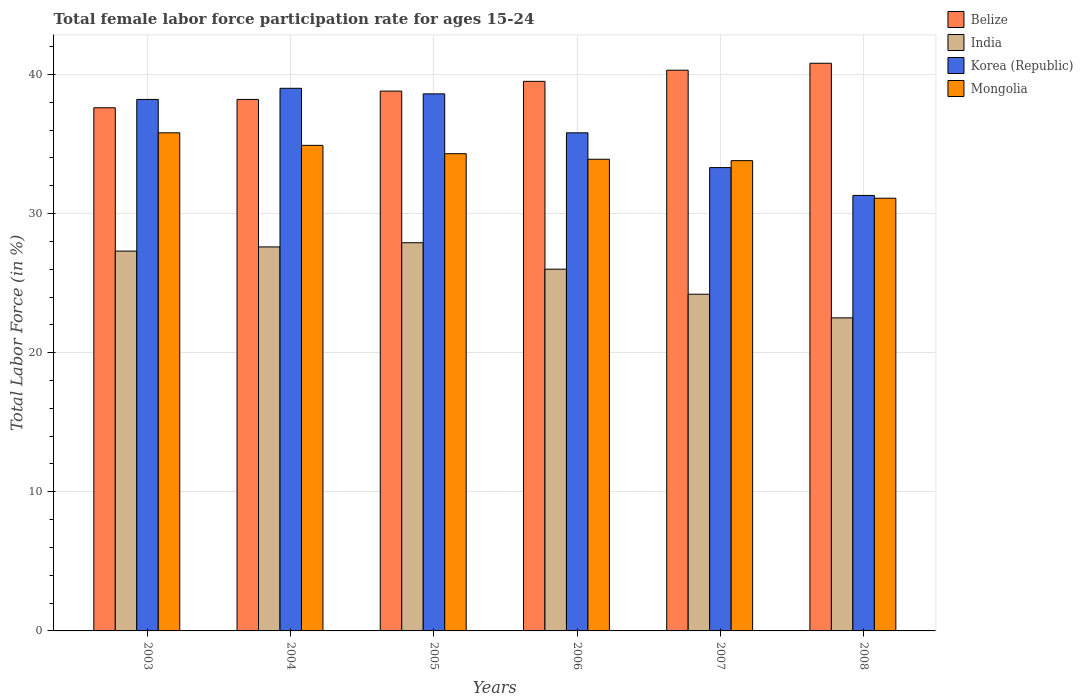How many groups of bars are there?
Provide a short and direct response. 6. Are the number of bars on each tick of the X-axis equal?
Offer a very short reply. Yes. How many bars are there on the 2nd tick from the left?
Keep it short and to the point. 4. In how many cases, is the number of bars for a given year not equal to the number of legend labels?
Your response must be concise. 0. What is the female labor force participation rate in India in 2006?
Provide a short and direct response. 26. Across all years, what is the minimum female labor force participation rate in Mongolia?
Offer a very short reply. 31.1. In which year was the female labor force participation rate in Belize maximum?
Provide a short and direct response. 2008. In which year was the female labor force participation rate in Korea (Republic) minimum?
Give a very brief answer. 2008. What is the total female labor force participation rate in Belize in the graph?
Your answer should be very brief. 235.2. What is the difference between the female labor force participation rate in Mongolia in 2003 and that in 2005?
Provide a short and direct response. 1.5. What is the difference between the female labor force participation rate in India in 2007 and the female labor force participation rate in Korea (Republic) in 2003?
Provide a short and direct response. -14. What is the average female labor force participation rate in Mongolia per year?
Ensure brevity in your answer.  33.97. In the year 2008, what is the difference between the female labor force participation rate in Korea (Republic) and female labor force participation rate in India?
Your answer should be very brief. 8.8. What is the ratio of the female labor force participation rate in Mongolia in 2005 to that in 2006?
Provide a succinct answer. 1.01. What is the difference between the highest and the second highest female labor force participation rate in India?
Offer a terse response. 0.3. What is the difference between the highest and the lowest female labor force participation rate in Mongolia?
Ensure brevity in your answer.  4.7. What does the 4th bar from the left in 2003 represents?
Provide a short and direct response. Mongolia. Does the graph contain any zero values?
Provide a succinct answer. No. How many legend labels are there?
Keep it short and to the point. 4. How are the legend labels stacked?
Make the answer very short. Vertical. What is the title of the graph?
Your response must be concise. Total female labor force participation rate for ages 15-24. Does "Somalia" appear as one of the legend labels in the graph?
Offer a very short reply. No. What is the Total Labor Force (in %) of Belize in 2003?
Keep it short and to the point. 37.6. What is the Total Labor Force (in %) in India in 2003?
Provide a succinct answer. 27.3. What is the Total Labor Force (in %) of Korea (Republic) in 2003?
Provide a succinct answer. 38.2. What is the Total Labor Force (in %) of Mongolia in 2003?
Keep it short and to the point. 35.8. What is the Total Labor Force (in %) of Belize in 2004?
Your answer should be compact. 38.2. What is the Total Labor Force (in %) in India in 2004?
Provide a succinct answer. 27.6. What is the Total Labor Force (in %) in Mongolia in 2004?
Keep it short and to the point. 34.9. What is the Total Labor Force (in %) in Belize in 2005?
Give a very brief answer. 38.8. What is the Total Labor Force (in %) of India in 2005?
Ensure brevity in your answer.  27.9. What is the Total Labor Force (in %) of Korea (Republic) in 2005?
Your answer should be very brief. 38.6. What is the Total Labor Force (in %) in Mongolia in 2005?
Offer a terse response. 34.3. What is the Total Labor Force (in %) of Belize in 2006?
Your answer should be compact. 39.5. What is the Total Labor Force (in %) in Korea (Republic) in 2006?
Your answer should be compact. 35.8. What is the Total Labor Force (in %) in Mongolia in 2006?
Offer a very short reply. 33.9. What is the Total Labor Force (in %) of Belize in 2007?
Make the answer very short. 40.3. What is the Total Labor Force (in %) of India in 2007?
Give a very brief answer. 24.2. What is the Total Labor Force (in %) in Korea (Republic) in 2007?
Ensure brevity in your answer.  33.3. What is the Total Labor Force (in %) in Mongolia in 2007?
Ensure brevity in your answer.  33.8. What is the Total Labor Force (in %) of Belize in 2008?
Offer a terse response. 40.8. What is the Total Labor Force (in %) in Korea (Republic) in 2008?
Keep it short and to the point. 31.3. What is the Total Labor Force (in %) of Mongolia in 2008?
Make the answer very short. 31.1. Across all years, what is the maximum Total Labor Force (in %) of Belize?
Provide a succinct answer. 40.8. Across all years, what is the maximum Total Labor Force (in %) of India?
Give a very brief answer. 27.9. Across all years, what is the maximum Total Labor Force (in %) in Mongolia?
Your answer should be compact. 35.8. Across all years, what is the minimum Total Labor Force (in %) in Belize?
Make the answer very short. 37.6. Across all years, what is the minimum Total Labor Force (in %) in India?
Your answer should be very brief. 22.5. Across all years, what is the minimum Total Labor Force (in %) of Korea (Republic)?
Keep it short and to the point. 31.3. Across all years, what is the minimum Total Labor Force (in %) in Mongolia?
Provide a short and direct response. 31.1. What is the total Total Labor Force (in %) of Belize in the graph?
Your response must be concise. 235.2. What is the total Total Labor Force (in %) of India in the graph?
Offer a terse response. 155.5. What is the total Total Labor Force (in %) in Korea (Republic) in the graph?
Your answer should be compact. 216.2. What is the total Total Labor Force (in %) in Mongolia in the graph?
Your answer should be compact. 203.8. What is the difference between the Total Labor Force (in %) of India in 2003 and that in 2004?
Your answer should be compact. -0.3. What is the difference between the Total Labor Force (in %) in Korea (Republic) in 2003 and that in 2004?
Your answer should be compact. -0.8. What is the difference between the Total Labor Force (in %) of Mongolia in 2003 and that in 2004?
Offer a terse response. 0.9. What is the difference between the Total Labor Force (in %) in Korea (Republic) in 2003 and that in 2005?
Give a very brief answer. -0.4. What is the difference between the Total Labor Force (in %) of Mongolia in 2003 and that in 2005?
Offer a terse response. 1.5. What is the difference between the Total Labor Force (in %) in India in 2003 and that in 2007?
Your answer should be compact. 3.1. What is the difference between the Total Labor Force (in %) in Belize in 2003 and that in 2008?
Your response must be concise. -3.2. What is the difference between the Total Labor Force (in %) of Mongolia in 2003 and that in 2008?
Your response must be concise. 4.7. What is the difference between the Total Labor Force (in %) of India in 2004 and that in 2005?
Offer a terse response. -0.3. What is the difference between the Total Labor Force (in %) of Korea (Republic) in 2004 and that in 2005?
Offer a very short reply. 0.4. What is the difference between the Total Labor Force (in %) of Belize in 2004 and that in 2006?
Keep it short and to the point. -1.3. What is the difference between the Total Labor Force (in %) of India in 2004 and that in 2006?
Give a very brief answer. 1.6. What is the difference between the Total Labor Force (in %) in Korea (Republic) in 2004 and that in 2006?
Keep it short and to the point. 3.2. What is the difference between the Total Labor Force (in %) of Belize in 2004 and that in 2007?
Offer a terse response. -2.1. What is the difference between the Total Labor Force (in %) of India in 2004 and that in 2007?
Keep it short and to the point. 3.4. What is the difference between the Total Labor Force (in %) in Korea (Republic) in 2004 and that in 2007?
Give a very brief answer. 5.7. What is the difference between the Total Labor Force (in %) in Mongolia in 2004 and that in 2007?
Your answer should be compact. 1.1. What is the difference between the Total Labor Force (in %) of Belize in 2004 and that in 2008?
Provide a succinct answer. -2.6. What is the difference between the Total Labor Force (in %) in India in 2004 and that in 2008?
Give a very brief answer. 5.1. What is the difference between the Total Labor Force (in %) in Belize in 2005 and that in 2006?
Keep it short and to the point. -0.7. What is the difference between the Total Labor Force (in %) of Korea (Republic) in 2005 and that in 2006?
Ensure brevity in your answer.  2.8. What is the difference between the Total Labor Force (in %) of Mongolia in 2005 and that in 2006?
Your answer should be compact. 0.4. What is the difference between the Total Labor Force (in %) in Belize in 2005 and that in 2007?
Make the answer very short. -1.5. What is the difference between the Total Labor Force (in %) of India in 2005 and that in 2007?
Provide a succinct answer. 3.7. What is the difference between the Total Labor Force (in %) of India in 2005 and that in 2008?
Your answer should be very brief. 5.4. What is the difference between the Total Labor Force (in %) in Mongolia in 2005 and that in 2008?
Offer a very short reply. 3.2. What is the difference between the Total Labor Force (in %) of India in 2006 and that in 2007?
Provide a short and direct response. 1.8. What is the difference between the Total Labor Force (in %) in Belize in 2006 and that in 2008?
Keep it short and to the point. -1.3. What is the difference between the Total Labor Force (in %) in Belize in 2003 and the Total Labor Force (in %) in India in 2004?
Ensure brevity in your answer.  10. What is the difference between the Total Labor Force (in %) of Belize in 2003 and the Total Labor Force (in %) of Korea (Republic) in 2004?
Offer a very short reply. -1.4. What is the difference between the Total Labor Force (in %) in Korea (Republic) in 2003 and the Total Labor Force (in %) in Mongolia in 2004?
Provide a succinct answer. 3.3. What is the difference between the Total Labor Force (in %) of Belize in 2003 and the Total Labor Force (in %) of India in 2005?
Provide a succinct answer. 9.7. What is the difference between the Total Labor Force (in %) in Belize in 2003 and the Total Labor Force (in %) in Korea (Republic) in 2005?
Your answer should be very brief. -1. What is the difference between the Total Labor Force (in %) in Belize in 2003 and the Total Labor Force (in %) in Mongolia in 2005?
Provide a succinct answer. 3.3. What is the difference between the Total Labor Force (in %) in Belize in 2003 and the Total Labor Force (in %) in India in 2006?
Provide a succinct answer. 11.6. What is the difference between the Total Labor Force (in %) of India in 2003 and the Total Labor Force (in %) of Korea (Republic) in 2006?
Offer a very short reply. -8.5. What is the difference between the Total Labor Force (in %) of Korea (Republic) in 2003 and the Total Labor Force (in %) of Mongolia in 2006?
Give a very brief answer. 4.3. What is the difference between the Total Labor Force (in %) of Belize in 2003 and the Total Labor Force (in %) of India in 2007?
Your response must be concise. 13.4. What is the difference between the Total Labor Force (in %) in Belize in 2003 and the Total Labor Force (in %) in Mongolia in 2007?
Ensure brevity in your answer.  3.8. What is the difference between the Total Labor Force (in %) in India in 2003 and the Total Labor Force (in %) in Mongolia in 2007?
Give a very brief answer. -6.5. What is the difference between the Total Labor Force (in %) in Belize in 2003 and the Total Labor Force (in %) in Korea (Republic) in 2008?
Keep it short and to the point. 6.3. What is the difference between the Total Labor Force (in %) of India in 2003 and the Total Labor Force (in %) of Korea (Republic) in 2008?
Your answer should be compact. -4. What is the difference between the Total Labor Force (in %) in India in 2003 and the Total Labor Force (in %) in Mongolia in 2008?
Provide a succinct answer. -3.8. What is the difference between the Total Labor Force (in %) in Belize in 2004 and the Total Labor Force (in %) in Korea (Republic) in 2005?
Offer a terse response. -0.4. What is the difference between the Total Labor Force (in %) of Belize in 2004 and the Total Labor Force (in %) of Mongolia in 2005?
Keep it short and to the point. 3.9. What is the difference between the Total Labor Force (in %) of India in 2004 and the Total Labor Force (in %) of Mongolia in 2005?
Provide a succinct answer. -6.7. What is the difference between the Total Labor Force (in %) in Belize in 2004 and the Total Labor Force (in %) in India in 2006?
Your answer should be compact. 12.2. What is the difference between the Total Labor Force (in %) in India in 2004 and the Total Labor Force (in %) in Korea (Republic) in 2006?
Keep it short and to the point. -8.2. What is the difference between the Total Labor Force (in %) in India in 2004 and the Total Labor Force (in %) in Mongolia in 2006?
Provide a short and direct response. -6.3. What is the difference between the Total Labor Force (in %) in Belize in 2004 and the Total Labor Force (in %) in Korea (Republic) in 2007?
Keep it short and to the point. 4.9. What is the difference between the Total Labor Force (in %) in India in 2004 and the Total Labor Force (in %) in Mongolia in 2007?
Ensure brevity in your answer.  -6.2. What is the difference between the Total Labor Force (in %) of Korea (Republic) in 2004 and the Total Labor Force (in %) of Mongolia in 2007?
Keep it short and to the point. 5.2. What is the difference between the Total Labor Force (in %) in Belize in 2004 and the Total Labor Force (in %) in Korea (Republic) in 2008?
Your answer should be very brief. 6.9. What is the difference between the Total Labor Force (in %) of Belize in 2004 and the Total Labor Force (in %) of Mongolia in 2008?
Provide a short and direct response. 7.1. What is the difference between the Total Labor Force (in %) in India in 2004 and the Total Labor Force (in %) in Korea (Republic) in 2008?
Offer a terse response. -3.7. What is the difference between the Total Labor Force (in %) in Belize in 2005 and the Total Labor Force (in %) in India in 2006?
Your answer should be compact. 12.8. What is the difference between the Total Labor Force (in %) of Belize in 2005 and the Total Labor Force (in %) of Mongolia in 2006?
Offer a very short reply. 4.9. What is the difference between the Total Labor Force (in %) in India in 2005 and the Total Labor Force (in %) in Korea (Republic) in 2006?
Ensure brevity in your answer.  -7.9. What is the difference between the Total Labor Force (in %) of India in 2005 and the Total Labor Force (in %) of Mongolia in 2006?
Your response must be concise. -6. What is the difference between the Total Labor Force (in %) in Belize in 2005 and the Total Labor Force (in %) in India in 2007?
Give a very brief answer. 14.6. What is the difference between the Total Labor Force (in %) of Belize in 2005 and the Total Labor Force (in %) of Mongolia in 2007?
Your response must be concise. 5. What is the difference between the Total Labor Force (in %) of India in 2005 and the Total Labor Force (in %) of Mongolia in 2007?
Ensure brevity in your answer.  -5.9. What is the difference between the Total Labor Force (in %) of Korea (Republic) in 2005 and the Total Labor Force (in %) of Mongolia in 2007?
Give a very brief answer. 4.8. What is the difference between the Total Labor Force (in %) in India in 2005 and the Total Labor Force (in %) in Korea (Republic) in 2008?
Your answer should be very brief. -3.4. What is the difference between the Total Labor Force (in %) in Korea (Republic) in 2005 and the Total Labor Force (in %) in Mongolia in 2008?
Offer a terse response. 7.5. What is the difference between the Total Labor Force (in %) in Belize in 2006 and the Total Labor Force (in %) in India in 2007?
Make the answer very short. 15.3. What is the difference between the Total Labor Force (in %) of Belize in 2006 and the Total Labor Force (in %) of Korea (Republic) in 2007?
Keep it short and to the point. 6.2. What is the difference between the Total Labor Force (in %) in India in 2006 and the Total Labor Force (in %) in Korea (Republic) in 2007?
Provide a succinct answer. -7.3. What is the difference between the Total Labor Force (in %) of India in 2006 and the Total Labor Force (in %) of Mongolia in 2007?
Provide a succinct answer. -7.8. What is the difference between the Total Labor Force (in %) of Korea (Republic) in 2006 and the Total Labor Force (in %) of Mongolia in 2007?
Provide a short and direct response. 2. What is the difference between the Total Labor Force (in %) in Korea (Republic) in 2006 and the Total Labor Force (in %) in Mongolia in 2008?
Make the answer very short. 4.7. What is the difference between the Total Labor Force (in %) in Belize in 2007 and the Total Labor Force (in %) in India in 2008?
Your answer should be compact. 17.8. What is the average Total Labor Force (in %) of Belize per year?
Your response must be concise. 39.2. What is the average Total Labor Force (in %) of India per year?
Provide a succinct answer. 25.92. What is the average Total Labor Force (in %) in Korea (Republic) per year?
Keep it short and to the point. 36.03. What is the average Total Labor Force (in %) in Mongolia per year?
Offer a very short reply. 33.97. In the year 2003, what is the difference between the Total Labor Force (in %) in Belize and Total Labor Force (in %) in India?
Offer a terse response. 10.3. In the year 2003, what is the difference between the Total Labor Force (in %) in India and Total Labor Force (in %) in Mongolia?
Provide a succinct answer. -8.5. In the year 2004, what is the difference between the Total Labor Force (in %) of Belize and Total Labor Force (in %) of India?
Your answer should be very brief. 10.6. In the year 2004, what is the difference between the Total Labor Force (in %) in Belize and Total Labor Force (in %) in Korea (Republic)?
Ensure brevity in your answer.  -0.8. In the year 2004, what is the difference between the Total Labor Force (in %) of India and Total Labor Force (in %) of Mongolia?
Offer a terse response. -7.3. In the year 2005, what is the difference between the Total Labor Force (in %) in Belize and Total Labor Force (in %) in India?
Your response must be concise. 10.9. In the year 2005, what is the difference between the Total Labor Force (in %) in Belize and Total Labor Force (in %) in Korea (Republic)?
Ensure brevity in your answer.  0.2. In the year 2005, what is the difference between the Total Labor Force (in %) in Korea (Republic) and Total Labor Force (in %) in Mongolia?
Make the answer very short. 4.3. In the year 2006, what is the difference between the Total Labor Force (in %) of Belize and Total Labor Force (in %) of India?
Offer a terse response. 13.5. In the year 2006, what is the difference between the Total Labor Force (in %) of Belize and Total Labor Force (in %) of Korea (Republic)?
Ensure brevity in your answer.  3.7. In the year 2006, what is the difference between the Total Labor Force (in %) in Belize and Total Labor Force (in %) in Mongolia?
Make the answer very short. 5.6. In the year 2006, what is the difference between the Total Labor Force (in %) of India and Total Labor Force (in %) of Mongolia?
Provide a succinct answer. -7.9. In the year 2007, what is the difference between the Total Labor Force (in %) of Belize and Total Labor Force (in %) of India?
Provide a succinct answer. 16.1. In the year 2007, what is the difference between the Total Labor Force (in %) of Belize and Total Labor Force (in %) of Mongolia?
Offer a terse response. 6.5. In the year 2007, what is the difference between the Total Labor Force (in %) in India and Total Labor Force (in %) in Korea (Republic)?
Give a very brief answer. -9.1. In the year 2007, what is the difference between the Total Labor Force (in %) of Korea (Republic) and Total Labor Force (in %) of Mongolia?
Your response must be concise. -0.5. In the year 2008, what is the difference between the Total Labor Force (in %) in Belize and Total Labor Force (in %) in Korea (Republic)?
Provide a short and direct response. 9.5. What is the ratio of the Total Labor Force (in %) of Belize in 2003 to that in 2004?
Provide a short and direct response. 0.98. What is the ratio of the Total Labor Force (in %) in India in 2003 to that in 2004?
Your response must be concise. 0.99. What is the ratio of the Total Labor Force (in %) in Korea (Republic) in 2003 to that in 2004?
Give a very brief answer. 0.98. What is the ratio of the Total Labor Force (in %) in Mongolia in 2003 to that in 2004?
Give a very brief answer. 1.03. What is the ratio of the Total Labor Force (in %) in Belize in 2003 to that in 2005?
Make the answer very short. 0.97. What is the ratio of the Total Labor Force (in %) in India in 2003 to that in 2005?
Make the answer very short. 0.98. What is the ratio of the Total Labor Force (in %) in Mongolia in 2003 to that in 2005?
Provide a short and direct response. 1.04. What is the ratio of the Total Labor Force (in %) of Belize in 2003 to that in 2006?
Your response must be concise. 0.95. What is the ratio of the Total Labor Force (in %) in Korea (Republic) in 2003 to that in 2006?
Provide a succinct answer. 1.07. What is the ratio of the Total Labor Force (in %) of Mongolia in 2003 to that in 2006?
Your answer should be compact. 1.06. What is the ratio of the Total Labor Force (in %) in Belize in 2003 to that in 2007?
Your answer should be compact. 0.93. What is the ratio of the Total Labor Force (in %) in India in 2003 to that in 2007?
Offer a terse response. 1.13. What is the ratio of the Total Labor Force (in %) of Korea (Republic) in 2003 to that in 2007?
Keep it short and to the point. 1.15. What is the ratio of the Total Labor Force (in %) in Mongolia in 2003 to that in 2007?
Your response must be concise. 1.06. What is the ratio of the Total Labor Force (in %) in Belize in 2003 to that in 2008?
Offer a terse response. 0.92. What is the ratio of the Total Labor Force (in %) of India in 2003 to that in 2008?
Ensure brevity in your answer.  1.21. What is the ratio of the Total Labor Force (in %) of Korea (Republic) in 2003 to that in 2008?
Your response must be concise. 1.22. What is the ratio of the Total Labor Force (in %) of Mongolia in 2003 to that in 2008?
Offer a very short reply. 1.15. What is the ratio of the Total Labor Force (in %) of Belize in 2004 to that in 2005?
Offer a very short reply. 0.98. What is the ratio of the Total Labor Force (in %) of India in 2004 to that in 2005?
Offer a terse response. 0.99. What is the ratio of the Total Labor Force (in %) in Korea (Republic) in 2004 to that in 2005?
Offer a terse response. 1.01. What is the ratio of the Total Labor Force (in %) in Mongolia in 2004 to that in 2005?
Give a very brief answer. 1.02. What is the ratio of the Total Labor Force (in %) of Belize in 2004 to that in 2006?
Give a very brief answer. 0.97. What is the ratio of the Total Labor Force (in %) in India in 2004 to that in 2006?
Offer a very short reply. 1.06. What is the ratio of the Total Labor Force (in %) of Korea (Republic) in 2004 to that in 2006?
Your answer should be compact. 1.09. What is the ratio of the Total Labor Force (in %) in Mongolia in 2004 to that in 2006?
Offer a terse response. 1.03. What is the ratio of the Total Labor Force (in %) in Belize in 2004 to that in 2007?
Your answer should be compact. 0.95. What is the ratio of the Total Labor Force (in %) in India in 2004 to that in 2007?
Offer a terse response. 1.14. What is the ratio of the Total Labor Force (in %) of Korea (Republic) in 2004 to that in 2007?
Your answer should be very brief. 1.17. What is the ratio of the Total Labor Force (in %) in Mongolia in 2004 to that in 2007?
Offer a terse response. 1.03. What is the ratio of the Total Labor Force (in %) in Belize in 2004 to that in 2008?
Offer a terse response. 0.94. What is the ratio of the Total Labor Force (in %) of India in 2004 to that in 2008?
Offer a terse response. 1.23. What is the ratio of the Total Labor Force (in %) of Korea (Republic) in 2004 to that in 2008?
Make the answer very short. 1.25. What is the ratio of the Total Labor Force (in %) of Mongolia in 2004 to that in 2008?
Provide a succinct answer. 1.12. What is the ratio of the Total Labor Force (in %) of Belize in 2005 to that in 2006?
Offer a very short reply. 0.98. What is the ratio of the Total Labor Force (in %) of India in 2005 to that in 2006?
Your answer should be compact. 1.07. What is the ratio of the Total Labor Force (in %) of Korea (Republic) in 2005 to that in 2006?
Offer a terse response. 1.08. What is the ratio of the Total Labor Force (in %) in Mongolia in 2005 to that in 2006?
Keep it short and to the point. 1.01. What is the ratio of the Total Labor Force (in %) in Belize in 2005 to that in 2007?
Give a very brief answer. 0.96. What is the ratio of the Total Labor Force (in %) of India in 2005 to that in 2007?
Your response must be concise. 1.15. What is the ratio of the Total Labor Force (in %) in Korea (Republic) in 2005 to that in 2007?
Your answer should be compact. 1.16. What is the ratio of the Total Labor Force (in %) in Mongolia in 2005 to that in 2007?
Ensure brevity in your answer.  1.01. What is the ratio of the Total Labor Force (in %) of Belize in 2005 to that in 2008?
Your answer should be compact. 0.95. What is the ratio of the Total Labor Force (in %) of India in 2005 to that in 2008?
Your answer should be very brief. 1.24. What is the ratio of the Total Labor Force (in %) in Korea (Republic) in 2005 to that in 2008?
Make the answer very short. 1.23. What is the ratio of the Total Labor Force (in %) of Mongolia in 2005 to that in 2008?
Ensure brevity in your answer.  1.1. What is the ratio of the Total Labor Force (in %) in Belize in 2006 to that in 2007?
Provide a short and direct response. 0.98. What is the ratio of the Total Labor Force (in %) in India in 2006 to that in 2007?
Give a very brief answer. 1.07. What is the ratio of the Total Labor Force (in %) in Korea (Republic) in 2006 to that in 2007?
Offer a very short reply. 1.08. What is the ratio of the Total Labor Force (in %) in Mongolia in 2006 to that in 2007?
Offer a terse response. 1. What is the ratio of the Total Labor Force (in %) of Belize in 2006 to that in 2008?
Your answer should be very brief. 0.97. What is the ratio of the Total Labor Force (in %) in India in 2006 to that in 2008?
Ensure brevity in your answer.  1.16. What is the ratio of the Total Labor Force (in %) of Korea (Republic) in 2006 to that in 2008?
Provide a succinct answer. 1.14. What is the ratio of the Total Labor Force (in %) of Mongolia in 2006 to that in 2008?
Your response must be concise. 1.09. What is the ratio of the Total Labor Force (in %) of Belize in 2007 to that in 2008?
Your response must be concise. 0.99. What is the ratio of the Total Labor Force (in %) of India in 2007 to that in 2008?
Keep it short and to the point. 1.08. What is the ratio of the Total Labor Force (in %) in Korea (Republic) in 2007 to that in 2008?
Offer a very short reply. 1.06. What is the ratio of the Total Labor Force (in %) in Mongolia in 2007 to that in 2008?
Provide a short and direct response. 1.09. What is the difference between the highest and the second highest Total Labor Force (in %) in Belize?
Provide a succinct answer. 0.5. What is the difference between the highest and the second highest Total Labor Force (in %) in Mongolia?
Keep it short and to the point. 0.9. What is the difference between the highest and the lowest Total Labor Force (in %) of Belize?
Keep it short and to the point. 3.2. What is the difference between the highest and the lowest Total Labor Force (in %) in Mongolia?
Make the answer very short. 4.7. 